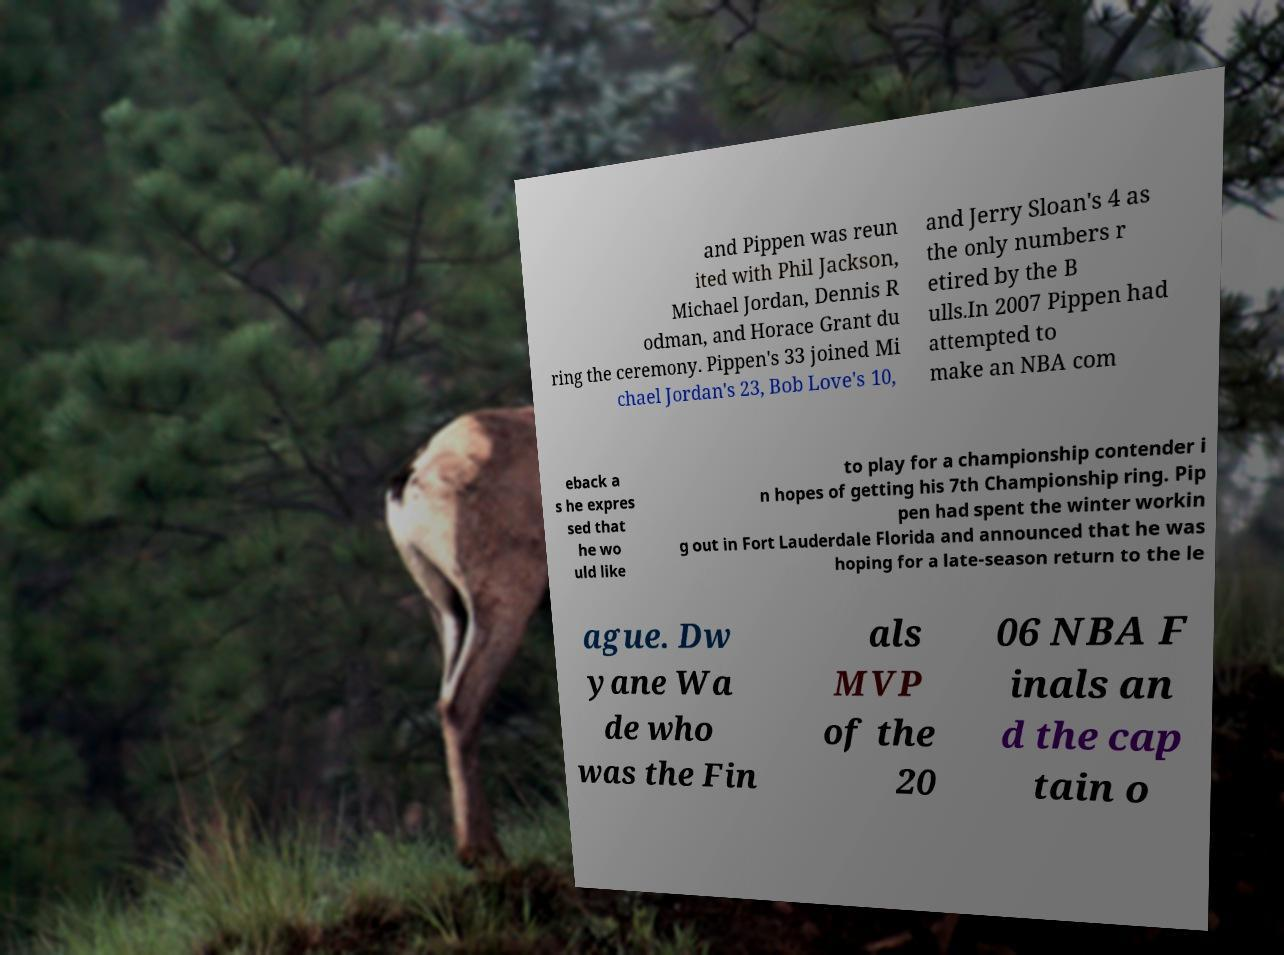For documentation purposes, I need the text within this image transcribed. Could you provide that? and Pippen was reun ited with Phil Jackson, Michael Jordan, Dennis R odman, and Horace Grant du ring the ceremony. Pippen's 33 joined Mi chael Jordan's 23, Bob Love's 10, and Jerry Sloan's 4 as the only numbers r etired by the B ulls.In 2007 Pippen had attempted to make an NBA com eback a s he expres sed that he wo uld like to play for a championship contender i n hopes of getting his 7th Championship ring. Pip pen had spent the winter workin g out in Fort Lauderdale Florida and announced that he was hoping for a late-season return to the le ague. Dw yane Wa de who was the Fin als MVP of the 20 06 NBA F inals an d the cap tain o 